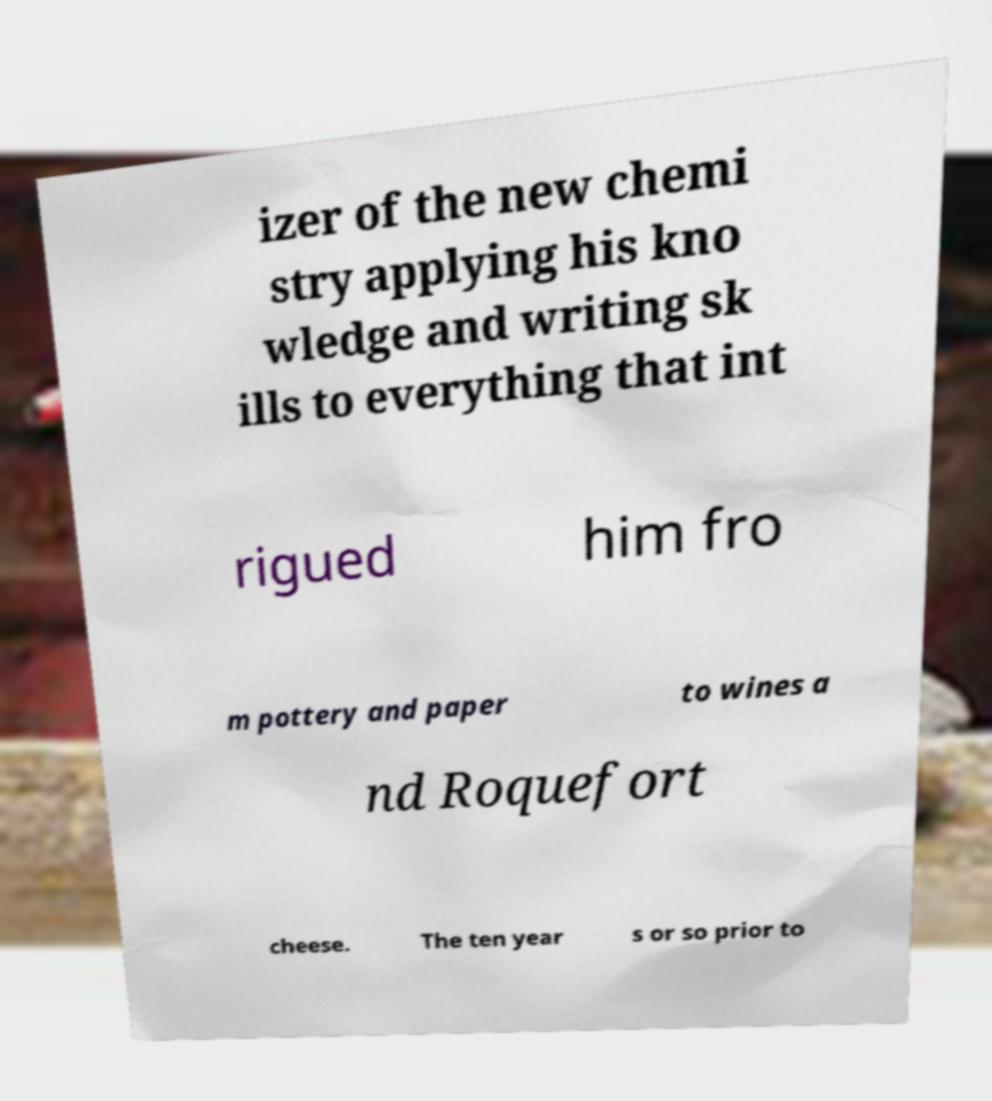I need the written content from this picture converted into text. Can you do that? izer of the new chemi stry applying his kno wledge and writing sk ills to everything that int rigued him fro m pottery and paper to wines a nd Roquefort cheese. The ten year s or so prior to 